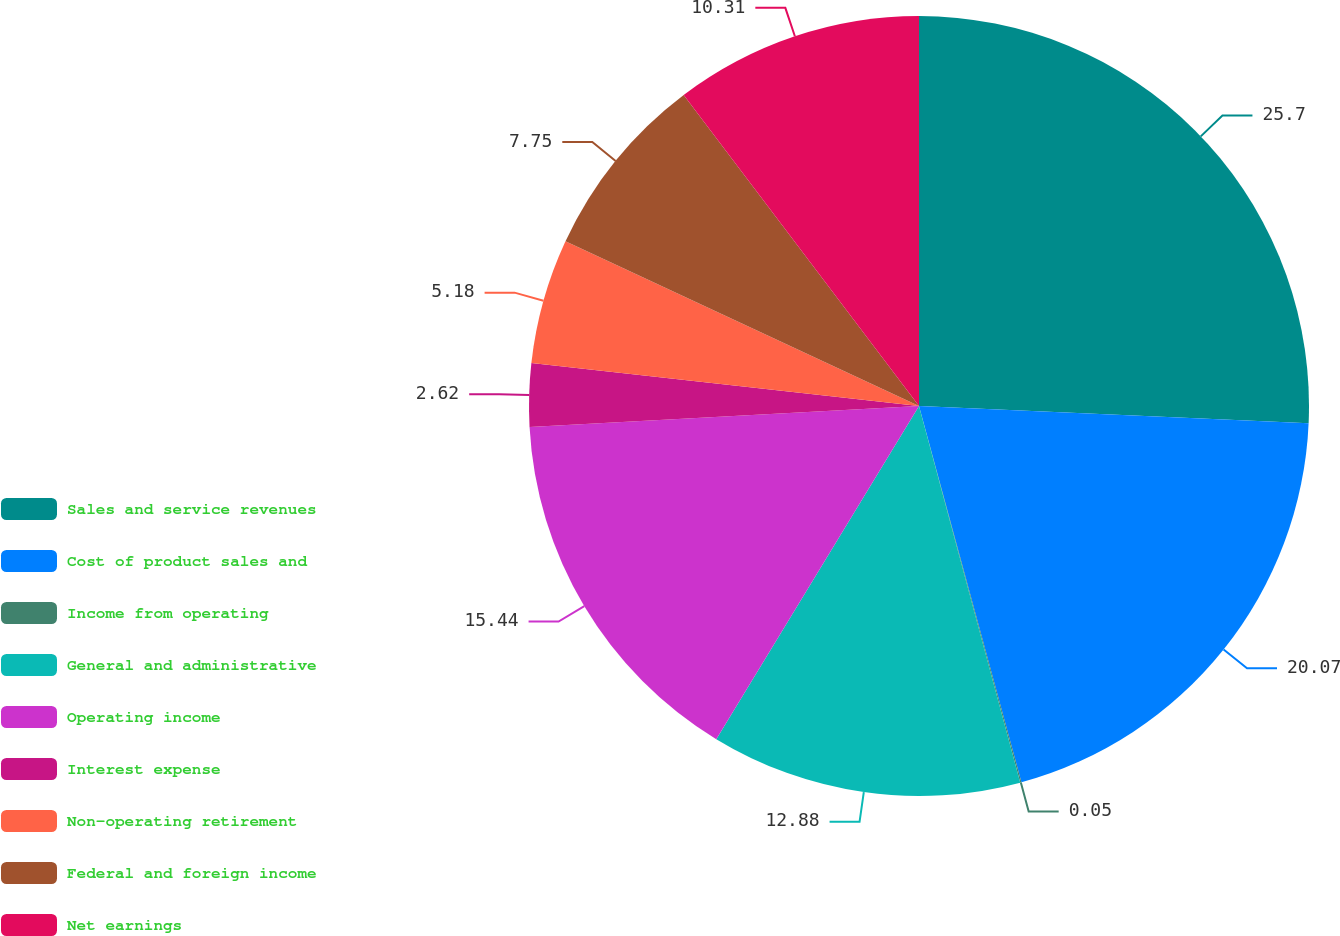Convert chart to OTSL. <chart><loc_0><loc_0><loc_500><loc_500><pie_chart><fcel>Sales and service revenues<fcel>Cost of product sales and<fcel>Income from operating<fcel>General and administrative<fcel>Operating income<fcel>Interest expense<fcel>Non-operating retirement<fcel>Federal and foreign income<fcel>Net earnings<nl><fcel>25.7%<fcel>20.07%<fcel>0.05%<fcel>12.88%<fcel>15.44%<fcel>2.62%<fcel>5.18%<fcel>7.75%<fcel>10.31%<nl></chart> 